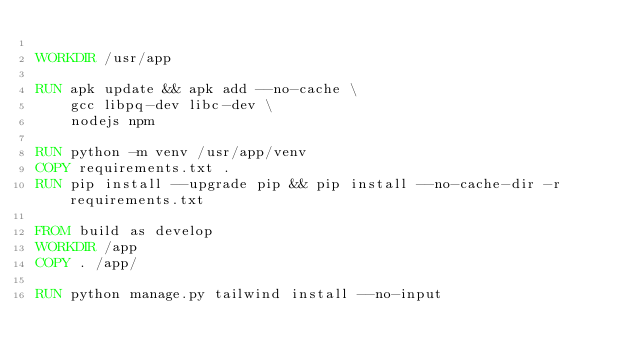<code> <loc_0><loc_0><loc_500><loc_500><_Dockerfile_>
WORKDIR /usr/app

RUN apk update && apk add --no-cache \
    gcc libpq-dev libc-dev \
    nodejs npm

RUN python -m venv /usr/app/venv
COPY requirements.txt .
RUN pip install --upgrade pip && pip install --no-cache-dir -r requirements.txt

FROM build as develop
WORKDIR /app
COPY . /app/

RUN python manage.py tailwind install --no-input
</code> 